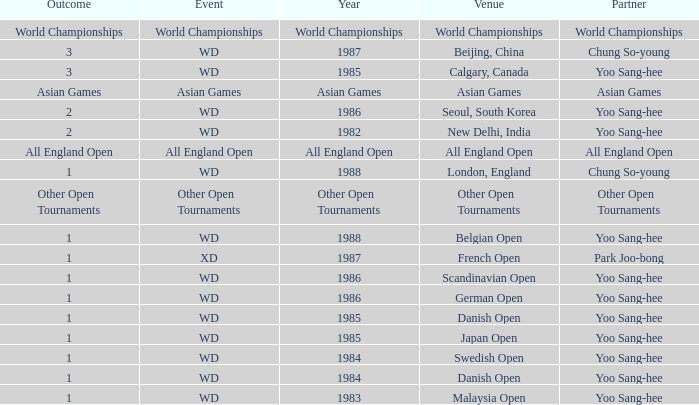In what Year did the German Open have Yoo Sang-Hee as Partner? 1986.0. 